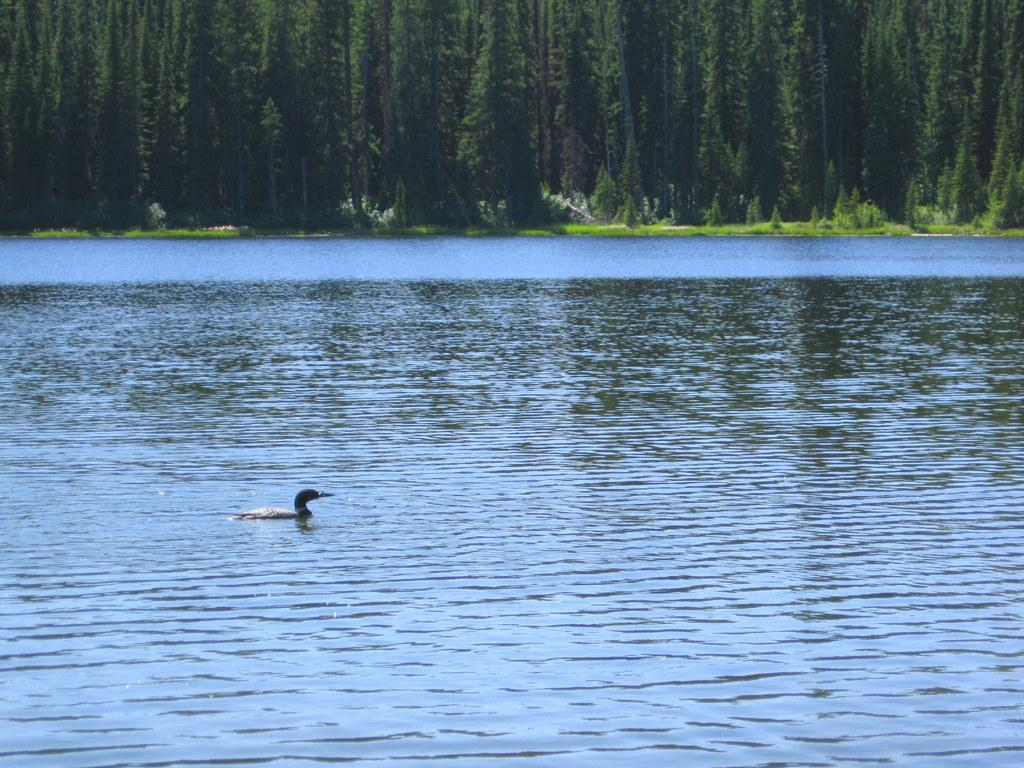What type of animal is in the image? There is a bird in the image. Where is the bird located? The bird is on the water. What can be seen in the background of the image? There are trees, plants, and grass in the background of the image. What type of machine can be seen in the image? There is no machine present in the image; it features a bird on the water with a background of trees, plants, and grass. 